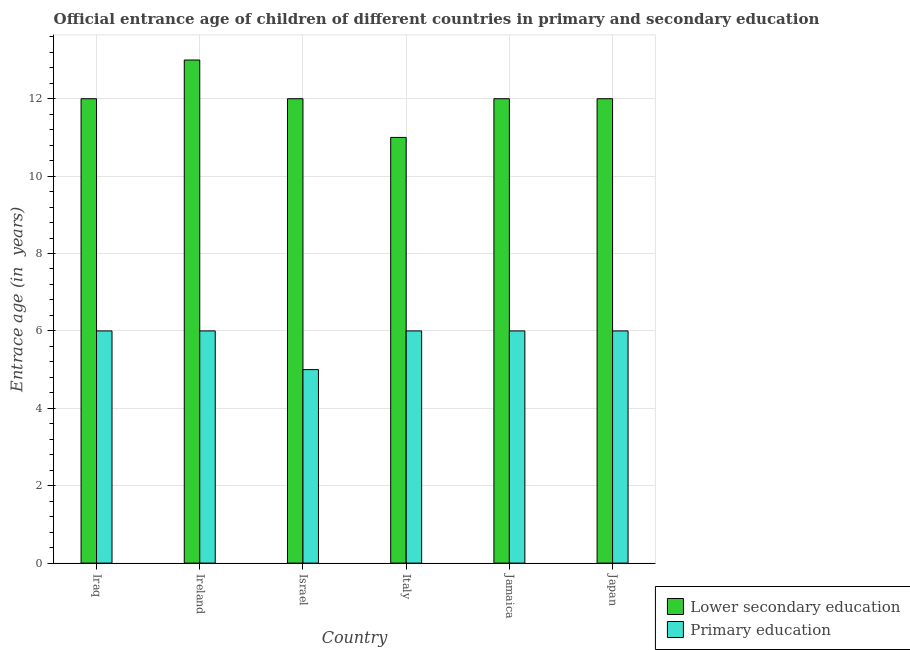How many different coloured bars are there?
Offer a very short reply. 2. Are the number of bars per tick equal to the number of legend labels?
Keep it short and to the point. Yes. What is the entrance age of chiildren in primary education in Jamaica?
Give a very brief answer. 6. Across all countries, what is the maximum entrance age of children in lower secondary education?
Ensure brevity in your answer.  13. Across all countries, what is the minimum entrance age of children in lower secondary education?
Ensure brevity in your answer.  11. In which country was the entrance age of chiildren in primary education maximum?
Your answer should be compact. Iraq. What is the total entrance age of chiildren in primary education in the graph?
Provide a succinct answer. 35. What is the difference between the entrance age of chiildren in primary education in Jamaica and that in Japan?
Ensure brevity in your answer.  0. What is the difference between the entrance age of chiildren in primary education in Israel and the entrance age of children in lower secondary education in Jamaica?
Your answer should be very brief. -7. What is the ratio of the entrance age of children in lower secondary education in Ireland to that in Jamaica?
Provide a short and direct response. 1.08. Is the difference between the entrance age of chiildren in primary education in Ireland and Israel greater than the difference between the entrance age of children in lower secondary education in Ireland and Israel?
Provide a succinct answer. No. What is the difference between the highest and the lowest entrance age of chiildren in primary education?
Give a very brief answer. 1. Is the sum of the entrance age of children in lower secondary education in Iraq and Ireland greater than the maximum entrance age of chiildren in primary education across all countries?
Offer a very short reply. Yes. What does the 2nd bar from the right in Ireland represents?
Ensure brevity in your answer.  Lower secondary education. How many bars are there?
Keep it short and to the point. 12. Are all the bars in the graph horizontal?
Ensure brevity in your answer.  No. How many countries are there in the graph?
Make the answer very short. 6. Are the values on the major ticks of Y-axis written in scientific E-notation?
Offer a terse response. No. Does the graph contain any zero values?
Your answer should be compact. No. Does the graph contain grids?
Your answer should be very brief. Yes. Where does the legend appear in the graph?
Ensure brevity in your answer.  Bottom right. How are the legend labels stacked?
Offer a very short reply. Vertical. What is the title of the graph?
Keep it short and to the point. Official entrance age of children of different countries in primary and secondary education. Does "Nonresident" appear as one of the legend labels in the graph?
Offer a very short reply. No. What is the label or title of the Y-axis?
Offer a terse response. Entrace age (in  years). What is the Entrace age (in  years) of Lower secondary education in Iraq?
Your answer should be compact. 12. What is the Entrace age (in  years) in Primary education in Ireland?
Ensure brevity in your answer.  6. What is the Entrace age (in  years) of Lower secondary education in Israel?
Your answer should be compact. 12. What is the Entrace age (in  years) of Primary education in Israel?
Offer a terse response. 5. What is the Entrace age (in  years) in Lower secondary education in Italy?
Offer a very short reply. 11. What is the Entrace age (in  years) in Lower secondary education in Japan?
Keep it short and to the point. 12. What is the Entrace age (in  years) in Primary education in Japan?
Your answer should be compact. 6. Across all countries, what is the maximum Entrace age (in  years) in Lower secondary education?
Provide a succinct answer. 13. Across all countries, what is the maximum Entrace age (in  years) of Primary education?
Ensure brevity in your answer.  6. What is the total Entrace age (in  years) of Primary education in the graph?
Offer a very short reply. 35. What is the difference between the Entrace age (in  years) of Lower secondary education in Iraq and that in Ireland?
Offer a very short reply. -1. What is the difference between the Entrace age (in  years) in Primary education in Iraq and that in Ireland?
Offer a very short reply. 0. What is the difference between the Entrace age (in  years) of Lower secondary education in Iraq and that in Israel?
Offer a very short reply. 0. What is the difference between the Entrace age (in  years) of Primary education in Iraq and that in Israel?
Your answer should be compact. 1. What is the difference between the Entrace age (in  years) of Lower secondary education in Iraq and that in Italy?
Provide a short and direct response. 1. What is the difference between the Entrace age (in  years) of Primary education in Iraq and that in Italy?
Your answer should be compact. 0. What is the difference between the Entrace age (in  years) in Lower secondary education in Iraq and that in Jamaica?
Provide a succinct answer. 0. What is the difference between the Entrace age (in  years) in Lower secondary education in Ireland and that in Italy?
Your answer should be compact. 2. What is the difference between the Entrace age (in  years) in Primary education in Ireland and that in Italy?
Make the answer very short. 0. What is the difference between the Entrace age (in  years) of Primary education in Ireland and that in Jamaica?
Offer a terse response. 0. What is the difference between the Entrace age (in  years) of Lower secondary education in Israel and that in Italy?
Offer a terse response. 1. What is the difference between the Entrace age (in  years) of Lower secondary education in Israel and that in Jamaica?
Give a very brief answer. 0. What is the difference between the Entrace age (in  years) in Lower secondary education in Israel and that in Japan?
Offer a very short reply. 0. What is the difference between the Entrace age (in  years) in Lower secondary education in Jamaica and that in Japan?
Your answer should be compact. 0. What is the difference between the Entrace age (in  years) of Lower secondary education in Iraq and the Entrace age (in  years) of Primary education in Ireland?
Your answer should be very brief. 6. What is the difference between the Entrace age (in  years) in Lower secondary education in Iraq and the Entrace age (in  years) in Primary education in Israel?
Offer a very short reply. 7. What is the difference between the Entrace age (in  years) in Lower secondary education in Iraq and the Entrace age (in  years) in Primary education in Japan?
Keep it short and to the point. 6. What is the difference between the Entrace age (in  years) of Lower secondary education in Ireland and the Entrace age (in  years) of Primary education in Israel?
Offer a terse response. 8. What is the difference between the Entrace age (in  years) of Lower secondary education in Ireland and the Entrace age (in  years) of Primary education in Jamaica?
Your answer should be compact. 7. What is the difference between the Entrace age (in  years) of Lower secondary education in Italy and the Entrace age (in  years) of Primary education in Japan?
Give a very brief answer. 5. What is the average Entrace age (in  years) of Primary education per country?
Provide a succinct answer. 5.83. What is the difference between the Entrace age (in  years) of Lower secondary education and Entrace age (in  years) of Primary education in Italy?
Make the answer very short. 5. What is the difference between the Entrace age (in  years) of Lower secondary education and Entrace age (in  years) of Primary education in Jamaica?
Provide a succinct answer. 6. What is the difference between the Entrace age (in  years) in Lower secondary education and Entrace age (in  years) in Primary education in Japan?
Your answer should be very brief. 6. What is the ratio of the Entrace age (in  years) in Primary education in Iraq to that in Israel?
Provide a short and direct response. 1.2. What is the ratio of the Entrace age (in  years) of Lower secondary education in Iraq to that in Italy?
Provide a short and direct response. 1.09. What is the ratio of the Entrace age (in  years) in Primary education in Iraq to that in Italy?
Provide a succinct answer. 1. What is the ratio of the Entrace age (in  years) in Lower secondary education in Iraq to that in Jamaica?
Your response must be concise. 1. What is the ratio of the Entrace age (in  years) of Primary education in Iraq to that in Jamaica?
Offer a terse response. 1. What is the ratio of the Entrace age (in  years) of Lower secondary education in Iraq to that in Japan?
Make the answer very short. 1. What is the ratio of the Entrace age (in  years) of Lower secondary education in Ireland to that in Israel?
Keep it short and to the point. 1.08. What is the ratio of the Entrace age (in  years) of Primary education in Ireland to that in Israel?
Ensure brevity in your answer.  1.2. What is the ratio of the Entrace age (in  years) of Lower secondary education in Ireland to that in Italy?
Your answer should be very brief. 1.18. What is the ratio of the Entrace age (in  years) in Lower secondary education in Ireland to that in Jamaica?
Offer a very short reply. 1.08. What is the ratio of the Entrace age (in  years) in Lower secondary education in Ireland to that in Japan?
Offer a terse response. 1.08. What is the ratio of the Entrace age (in  years) in Lower secondary education in Israel to that in Japan?
Make the answer very short. 1. What is the ratio of the Entrace age (in  years) of Lower secondary education in Italy to that in Jamaica?
Your answer should be compact. 0.92. What is the ratio of the Entrace age (in  years) in Primary education in Italy to that in Jamaica?
Your answer should be compact. 1. What is the ratio of the Entrace age (in  years) of Primary education in Italy to that in Japan?
Your answer should be compact. 1. What is the ratio of the Entrace age (in  years) of Lower secondary education in Jamaica to that in Japan?
Keep it short and to the point. 1. 